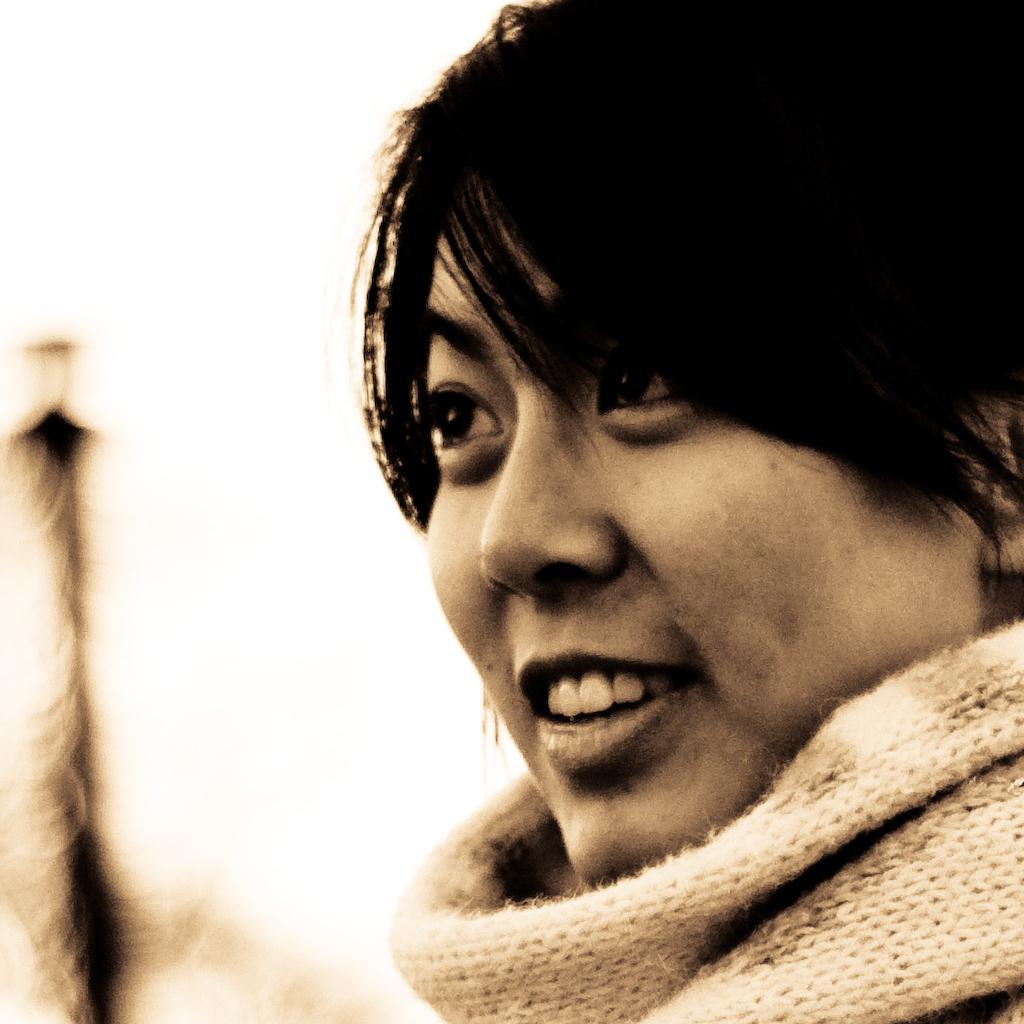What is the main subject of the image? There is a person in the image. Can you describe the background of the image? The background of the image is blurred. What type of list is the girl holding in the image? There is no girl or list present in the image; it only features a person with a blurred background. 